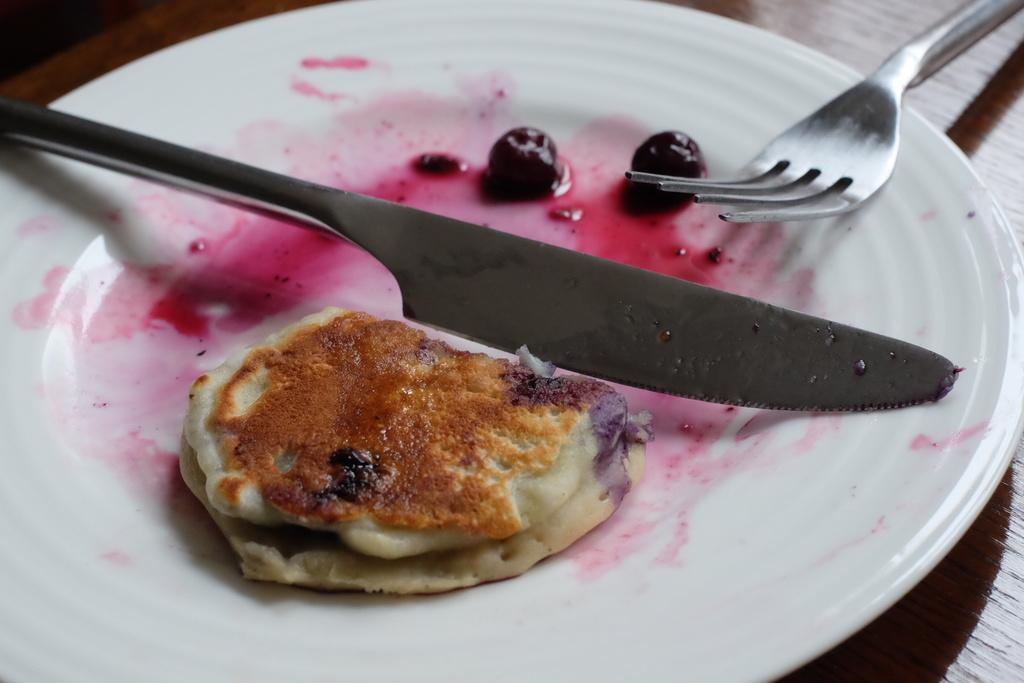What type of surface is visible in the image? There is a wooden surface in the image. What is placed on the wooden surface? There is a white plate on the wooden surface. What utensils are on the white plate? There is a knife and a fork on the white plate. What is the purpose of the utensils on the plate? The knife and fork are likely used for cutting and eating food. What can be inferred about the presence of food on the plate? There is food on the white plate, which suggests that someone might be preparing or serving a meal. What type of plants are growing on the page in the image? There is no page or plants present in the image; it features a wooden surface with a white plate, a knife, a fork, and food. 